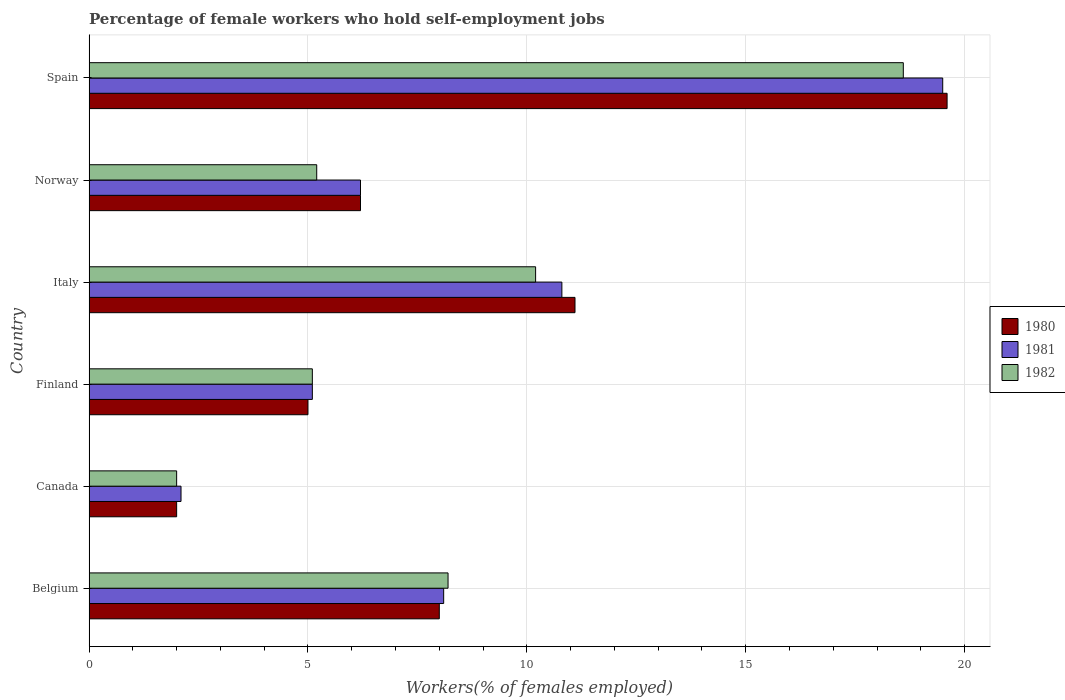Are the number of bars per tick equal to the number of legend labels?
Provide a short and direct response. Yes. Are the number of bars on each tick of the Y-axis equal?
Give a very brief answer. Yes. How many bars are there on the 3rd tick from the bottom?
Your answer should be very brief. 3. What is the label of the 3rd group of bars from the top?
Offer a terse response. Italy. What is the percentage of self-employed female workers in 1982 in Spain?
Keep it short and to the point. 18.6. Across all countries, what is the maximum percentage of self-employed female workers in 1980?
Ensure brevity in your answer.  19.6. In which country was the percentage of self-employed female workers in 1981 maximum?
Your answer should be compact. Spain. What is the total percentage of self-employed female workers in 1981 in the graph?
Provide a succinct answer. 51.8. What is the difference between the percentage of self-employed female workers in 1981 in Finland and that in Spain?
Keep it short and to the point. -14.4. What is the difference between the percentage of self-employed female workers in 1980 in Spain and the percentage of self-employed female workers in 1981 in Belgium?
Keep it short and to the point. 11.5. What is the average percentage of self-employed female workers in 1982 per country?
Make the answer very short. 8.22. What is the difference between the percentage of self-employed female workers in 1981 and percentage of self-employed female workers in 1980 in Belgium?
Ensure brevity in your answer.  0.1. What is the ratio of the percentage of self-employed female workers in 1980 in Canada to that in Norway?
Offer a very short reply. 0.32. Is the difference between the percentage of self-employed female workers in 1981 in Italy and Norway greater than the difference between the percentage of self-employed female workers in 1980 in Italy and Norway?
Your response must be concise. No. What is the difference between the highest and the second highest percentage of self-employed female workers in 1982?
Your response must be concise. 8.4. What is the difference between the highest and the lowest percentage of self-employed female workers in 1980?
Offer a very short reply. 17.6. What does the 2nd bar from the top in Canada represents?
Offer a terse response. 1981. What does the 3rd bar from the bottom in Italy represents?
Offer a terse response. 1982. How many bars are there?
Offer a very short reply. 18. Are all the bars in the graph horizontal?
Make the answer very short. Yes. What is the difference between two consecutive major ticks on the X-axis?
Your answer should be compact. 5. How many legend labels are there?
Your answer should be very brief. 3. How are the legend labels stacked?
Offer a very short reply. Vertical. What is the title of the graph?
Provide a succinct answer. Percentage of female workers who hold self-employment jobs. Does "1966" appear as one of the legend labels in the graph?
Provide a short and direct response. No. What is the label or title of the X-axis?
Keep it short and to the point. Workers(% of females employed). What is the Workers(% of females employed) of 1980 in Belgium?
Offer a very short reply. 8. What is the Workers(% of females employed) of 1981 in Belgium?
Offer a very short reply. 8.1. What is the Workers(% of females employed) of 1982 in Belgium?
Offer a very short reply. 8.2. What is the Workers(% of females employed) in 1980 in Canada?
Make the answer very short. 2. What is the Workers(% of females employed) in 1981 in Canada?
Provide a succinct answer. 2.1. What is the Workers(% of females employed) of 1980 in Finland?
Offer a terse response. 5. What is the Workers(% of females employed) of 1981 in Finland?
Keep it short and to the point. 5.1. What is the Workers(% of females employed) of 1982 in Finland?
Ensure brevity in your answer.  5.1. What is the Workers(% of females employed) of 1980 in Italy?
Provide a short and direct response. 11.1. What is the Workers(% of females employed) in 1981 in Italy?
Keep it short and to the point. 10.8. What is the Workers(% of females employed) of 1982 in Italy?
Give a very brief answer. 10.2. What is the Workers(% of females employed) of 1980 in Norway?
Your response must be concise. 6.2. What is the Workers(% of females employed) of 1981 in Norway?
Keep it short and to the point. 6.2. What is the Workers(% of females employed) in 1982 in Norway?
Provide a short and direct response. 5.2. What is the Workers(% of females employed) in 1980 in Spain?
Provide a short and direct response. 19.6. What is the Workers(% of females employed) in 1982 in Spain?
Give a very brief answer. 18.6. Across all countries, what is the maximum Workers(% of females employed) of 1980?
Ensure brevity in your answer.  19.6. Across all countries, what is the maximum Workers(% of females employed) of 1981?
Your answer should be very brief. 19.5. Across all countries, what is the maximum Workers(% of females employed) of 1982?
Your response must be concise. 18.6. Across all countries, what is the minimum Workers(% of females employed) in 1981?
Make the answer very short. 2.1. Across all countries, what is the minimum Workers(% of females employed) in 1982?
Provide a succinct answer. 2. What is the total Workers(% of females employed) in 1980 in the graph?
Ensure brevity in your answer.  51.9. What is the total Workers(% of females employed) of 1981 in the graph?
Provide a succinct answer. 51.8. What is the total Workers(% of females employed) in 1982 in the graph?
Provide a short and direct response. 49.3. What is the difference between the Workers(% of females employed) in 1982 in Belgium and that in Canada?
Provide a short and direct response. 6.2. What is the difference between the Workers(% of females employed) in 1981 in Belgium and that in Finland?
Make the answer very short. 3. What is the difference between the Workers(% of females employed) in 1982 in Belgium and that in Finland?
Provide a succinct answer. 3.1. What is the difference between the Workers(% of females employed) of 1980 in Belgium and that in Italy?
Give a very brief answer. -3.1. What is the difference between the Workers(% of females employed) of 1981 in Belgium and that in Italy?
Ensure brevity in your answer.  -2.7. What is the difference between the Workers(% of females employed) in 1982 in Belgium and that in Italy?
Offer a very short reply. -2. What is the difference between the Workers(% of females employed) of 1981 in Belgium and that in Spain?
Your response must be concise. -11.4. What is the difference between the Workers(% of females employed) in 1982 in Belgium and that in Spain?
Your response must be concise. -10.4. What is the difference between the Workers(% of females employed) in 1980 in Canada and that in Norway?
Provide a succinct answer. -4.2. What is the difference between the Workers(% of females employed) of 1982 in Canada and that in Norway?
Your answer should be compact. -3.2. What is the difference between the Workers(% of females employed) in 1980 in Canada and that in Spain?
Make the answer very short. -17.6. What is the difference between the Workers(% of females employed) of 1981 in Canada and that in Spain?
Your answer should be very brief. -17.4. What is the difference between the Workers(% of females employed) in 1982 in Canada and that in Spain?
Offer a terse response. -16.6. What is the difference between the Workers(% of females employed) of 1982 in Finland and that in Italy?
Offer a terse response. -5.1. What is the difference between the Workers(% of females employed) of 1980 in Finland and that in Norway?
Ensure brevity in your answer.  -1.2. What is the difference between the Workers(% of females employed) in 1982 in Finland and that in Norway?
Offer a very short reply. -0.1. What is the difference between the Workers(% of females employed) of 1980 in Finland and that in Spain?
Offer a terse response. -14.6. What is the difference between the Workers(% of females employed) in 1981 in Finland and that in Spain?
Provide a short and direct response. -14.4. What is the difference between the Workers(% of females employed) in 1980 in Italy and that in Norway?
Make the answer very short. 4.9. What is the difference between the Workers(% of females employed) of 1980 in Italy and that in Spain?
Provide a short and direct response. -8.5. What is the difference between the Workers(% of females employed) in 1981 in Italy and that in Spain?
Offer a terse response. -8.7. What is the difference between the Workers(% of females employed) in 1982 in Italy and that in Spain?
Keep it short and to the point. -8.4. What is the difference between the Workers(% of females employed) of 1980 in Norway and that in Spain?
Provide a succinct answer. -13.4. What is the difference between the Workers(% of females employed) in 1982 in Norway and that in Spain?
Offer a very short reply. -13.4. What is the difference between the Workers(% of females employed) of 1980 in Belgium and the Workers(% of females employed) of 1981 in Canada?
Provide a succinct answer. 5.9. What is the difference between the Workers(% of females employed) of 1981 in Belgium and the Workers(% of females employed) of 1982 in Canada?
Your answer should be very brief. 6.1. What is the difference between the Workers(% of females employed) in 1981 in Belgium and the Workers(% of females employed) in 1982 in Finland?
Ensure brevity in your answer.  3. What is the difference between the Workers(% of females employed) in 1980 in Belgium and the Workers(% of females employed) in 1981 in Italy?
Your answer should be compact. -2.8. What is the difference between the Workers(% of females employed) of 1981 in Belgium and the Workers(% of females employed) of 1982 in Norway?
Provide a succinct answer. 2.9. What is the difference between the Workers(% of females employed) of 1981 in Belgium and the Workers(% of females employed) of 1982 in Spain?
Make the answer very short. -10.5. What is the difference between the Workers(% of females employed) in 1980 in Canada and the Workers(% of females employed) in 1982 in Finland?
Ensure brevity in your answer.  -3.1. What is the difference between the Workers(% of females employed) in 1981 in Canada and the Workers(% of females employed) in 1982 in Finland?
Offer a terse response. -3. What is the difference between the Workers(% of females employed) in 1980 in Canada and the Workers(% of females employed) in 1982 in Italy?
Provide a succinct answer. -8.2. What is the difference between the Workers(% of females employed) in 1981 in Canada and the Workers(% of females employed) in 1982 in Norway?
Make the answer very short. -3.1. What is the difference between the Workers(% of females employed) of 1980 in Canada and the Workers(% of females employed) of 1981 in Spain?
Offer a very short reply. -17.5. What is the difference between the Workers(% of females employed) of 1980 in Canada and the Workers(% of females employed) of 1982 in Spain?
Give a very brief answer. -16.6. What is the difference between the Workers(% of females employed) in 1981 in Canada and the Workers(% of females employed) in 1982 in Spain?
Your response must be concise. -16.5. What is the difference between the Workers(% of females employed) in 1980 in Finland and the Workers(% of females employed) in 1982 in Italy?
Provide a short and direct response. -5.2. What is the difference between the Workers(% of females employed) of 1980 in Finland and the Workers(% of females employed) of 1982 in Norway?
Provide a succinct answer. -0.2. What is the difference between the Workers(% of females employed) of 1980 in Italy and the Workers(% of females employed) of 1981 in Norway?
Keep it short and to the point. 4.9. What is the difference between the Workers(% of females employed) in 1980 in Italy and the Workers(% of females employed) in 1982 in Norway?
Offer a terse response. 5.9. What is the difference between the Workers(% of females employed) of 1981 in Italy and the Workers(% of females employed) of 1982 in Norway?
Keep it short and to the point. 5.6. What is the difference between the Workers(% of females employed) in 1980 in Italy and the Workers(% of females employed) in 1982 in Spain?
Provide a succinct answer. -7.5. What is the difference between the Workers(% of females employed) of 1981 in Italy and the Workers(% of females employed) of 1982 in Spain?
Provide a succinct answer. -7.8. What is the difference between the Workers(% of females employed) in 1980 in Norway and the Workers(% of females employed) in 1981 in Spain?
Offer a very short reply. -13.3. What is the difference between the Workers(% of females employed) in 1980 in Norway and the Workers(% of females employed) in 1982 in Spain?
Provide a short and direct response. -12.4. What is the average Workers(% of females employed) of 1980 per country?
Your response must be concise. 8.65. What is the average Workers(% of females employed) of 1981 per country?
Ensure brevity in your answer.  8.63. What is the average Workers(% of females employed) of 1982 per country?
Offer a very short reply. 8.22. What is the difference between the Workers(% of females employed) of 1980 and Workers(% of females employed) of 1981 in Belgium?
Keep it short and to the point. -0.1. What is the difference between the Workers(% of females employed) in 1980 and Workers(% of females employed) in 1982 in Belgium?
Offer a terse response. -0.2. What is the difference between the Workers(% of females employed) in 1981 and Workers(% of females employed) in 1982 in Belgium?
Provide a succinct answer. -0.1. What is the difference between the Workers(% of females employed) in 1980 and Workers(% of females employed) in 1981 in Canada?
Offer a very short reply. -0.1. What is the difference between the Workers(% of females employed) of 1980 and Workers(% of females employed) of 1982 in Finland?
Make the answer very short. -0.1. What is the difference between the Workers(% of females employed) of 1981 and Workers(% of females employed) of 1982 in Finland?
Provide a succinct answer. 0. What is the difference between the Workers(% of females employed) in 1981 and Workers(% of females employed) in 1982 in Italy?
Your answer should be compact. 0.6. What is the difference between the Workers(% of females employed) in 1980 and Workers(% of females employed) in 1982 in Norway?
Provide a succinct answer. 1. What is the difference between the Workers(% of females employed) of 1980 and Workers(% of females employed) of 1981 in Spain?
Your response must be concise. 0.1. What is the difference between the Workers(% of females employed) in 1980 and Workers(% of females employed) in 1982 in Spain?
Keep it short and to the point. 1. What is the difference between the Workers(% of females employed) of 1981 and Workers(% of females employed) of 1982 in Spain?
Give a very brief answer. 0.9. What is the ratio of the Workers(% of females employed) in 1981 in Belgium to that in Canada?
Ensure brevity in your answer.  3.86. What is the ratio of the Workers(% of females employed) in 1981 in Belgium to that in Finland?
Give a very brief answer. 1.59. What is the ratio of the Workers(% of females employed) in 1982 in Belgium to that in Finland?
Your response must be concise. 1.61. What is the ratio of the Workers(% of females employed) in 1980 in Belgium to that in Italy?
Offer a very short reply. 0.72. What is the ratio of the Workers(% of females employed) in 1982 in Belgium to that in Italy?
Provide a succinct answer. 0.8. What is the ratio of the Workers(% of females employed) of 1980 in Belgium to that in Norway?
Ensure brevity in your answer.  1.29. What is the ratio of the Workers(% of females employed) of 1981 in Belgium to that in Norway?
Keep it short and to the point. 1.31. What is the ratio of the Workers(% of females employed) of 1982 in Belgium to that in Norway?
Provide a short and direct response. 1.58. What is the ratio of the Workers(% of females employed) of 1980 in Belgium to that in Spain?
Keep it short and to the point. 0.41. What is the ratio of the Workers(% of females employed) of 1981 in Belgium to that in Spain?
Make the answer very short. 0.42. What is the ratio of the Workers(% of females employed) of 1982 in Belgium to that in Spain?
Ensure brevity in your answer.  0.44. What is the ratio of the Workers(% of females employed) in 1981 in Canada to that in Finland?
Give a very brief answer. 0.41. What is the ratio of the Workers(% of females employed) in 1982 in Canada to that in Finland?
Ensure brevity in your answer.  0.39. What is the ratio of the Workers(% of females employed) of 1980 in Canada to that in Italy?
Offer a terse response. 0.18. What is the ratio of the Workers(% of females employed) in 1981 in Canada to that in Italy?
Make the answer very short. 0.19. What is the ratio of the Workers(% of females employed) in 1982 in Canada to that in Italy?
Make the answer very short. 0.2. What is the ratio of the Workers(% of females employed) of 1980 in Canada to that in Norway?
Your response must be concise. 0.32. What is the ratio of the Workers(% of females employed) of 1981 in Canada to that in Norway?
Offer a terse response. 0.34. What is the ratio of the Workers(% of females employed) in 1982 in Canada to that in Norway?
Your response must be concise. 0.38. What is the ratio of the Workers(% of females employed) in 1980 in Canada to that in Spain?
Your answer should be compact. 0.1. What is the ratio of the Workers(% of females employed) of 1981 in Canada to that in Spain?
Provide a succinct answer. 0.11. What is the ratio of the Workers(% of females employed) in 1982 in Canada to that in Spain?
Offer a very short reply. 0.11. What is the ratio of the Workers(% of females employed) of 1980 in Finland to that in Italy?
Provide a short and direct response. 0.45. What is the ratio of the Workers(% of females employed) in 1981 in Finland to that in Italy?
Your answer should be compact. 0.47. What is the ratio of the Workers(% of females employed) of 1982 in Finland to that in Italy?
Offer a very short reply. 0.5. What is the ratio of the Workers(% of females employed) of 1980 in Finland to that in Norway?
Offer a very short reply. 0.81. What is the ratio of the Workers(% of females employed) of 1981 in Finland to that in Norway?
Provide a succinct answer. 0.82. What is the ratio of the Workers(% of females employed) of 1982 in Finland to that in Norway?
Give a very brief answer. 0.98. What is the ratio of the Workers(% of females employed) in 1980 in Finland to that in Spain?
Ensure brevity in your answer.  0.26. What is the ratio of the Workers(% of females employed) in 1981 in Finland to that in Spain?
Your answer should be compact. 0.26. What is the ratio of the Workers(% of females employed) in 1982 in Finland to that in Spain?
Ensure brevity in your answer.  0.27. What is the ratio of the Workers(% of females employed) of 1980 in Italy to that in Norway?
Make the answer very short. 1.79. What is the ratio of the Workers(% of females employed) in 1981 in Italy to that in Norway?
Your answer should be very brief. 1.74. What is the ratio of the Workers(% of females employed) in 1982 in Italy to that in Norway?
Offer a very short reply. 1.96. What is the ratio of the Workers(% of females employed) in 1980 in Italy to that in Spain?
Make the answer very short. 0.57. What is the ratio of the Workers(% of females employed) of 1981 in Italy to that in Spain?
Offer a terse response. 0.55. What is the ratio of the Workers(% of females employed) in 1982 in Italy to that in Spain?
Provide a short and direct response. 0.55. What is the ratio of the Workers(% of females employed) of 1980 in Norway to that in Spain?
Make the answer very short. 0.32. What is the ratio of the Workers(% of females employed) of 1981 in Norway to that in Spain?
Provide a short and direct response. 0.32. What is the ratio of the Workers(% of females employed) of 1982 in Norway to that in Spain?
Offer a terse response. 0.28. What is the difference between the highest and the second highest Workers(% of females employed) of 1980?
Offer a terse response. 8.5. What is the difference between the highest and the second highest Workers(% of females employed) of 1981?
Your response must be concise. 8.7. What is the difference between the highest and the second highest Workers(% of females employed) of 1982?
Your answer should be very brief. 8.4. What is the difference between the highest and the lowest Workers(% of females employed) of 1982?
Keep it short and to the point. 16.6. 